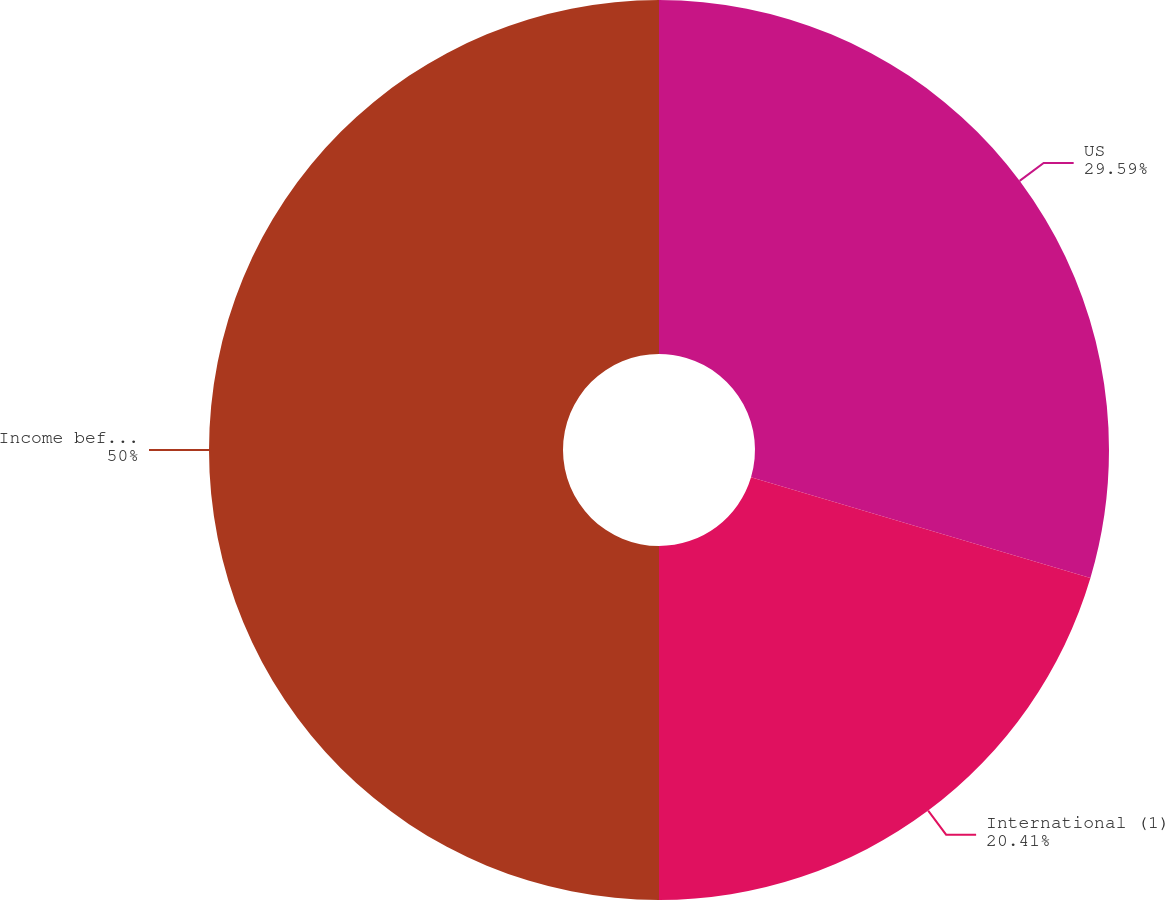Convert chart to OTSL. <chart><loc_0><loc_0><loc_500><loc_500><pie_chart><fcel>US<fcel>International (1)<fcel>Income before income taxes<nl><fcel>29.59%<fcel>20.41%<fcel>50.0%<nl></chart> 